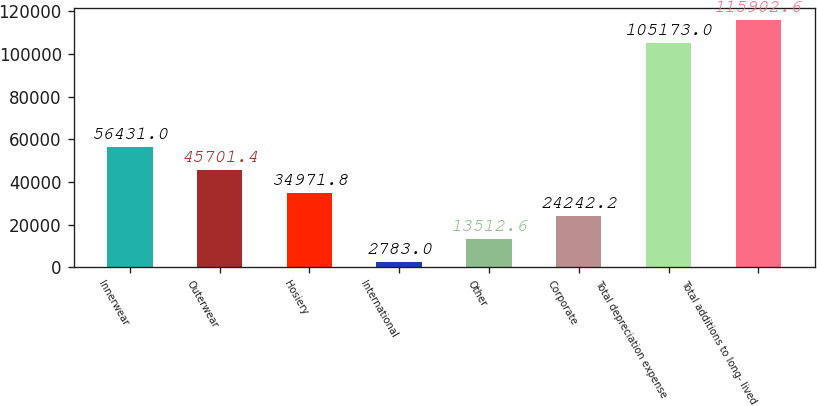Convert chart. <chart><loc_0><loc_0><loc_500><loc_500><bar_chart><fcel>Innerwear<fcel>Outerwear<fcel>Hosiery<fcel>International<fcel>Other<fcel>Corporate<fcel>Total depreciation expense<fcel>Total additions to long- lived<nl><fcel>56431<fcel>45701.4<fcel>34971.8<fcel>2783<fcel>13512.6<fcel>24242.2<fcel>105173<fcel>115903<nl></chart> 